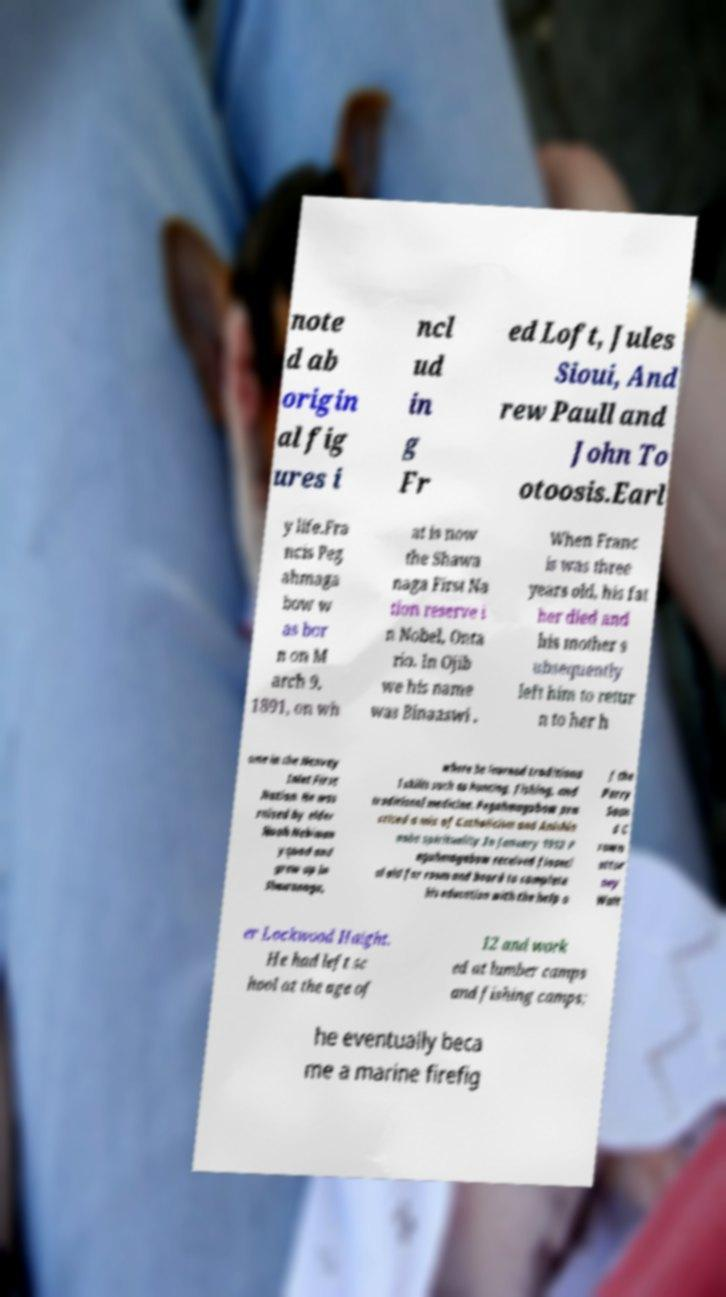What messages or text are displayed in this image? I need them in a readable, typed format. note d ab origin al fig ures i ncl ud in g Fr ed Loft, Jules Sioui, And rew Paull and John To otoosis.Earl y life.Fra ncis Peg ahmaga bow w as bor n on M arch 9, 1891, on wh at is now the Shawa naga First Na tion reserve i n Nobel, Onta rio. In Ojib we his name was Binaaswi . When Franc is was three years old, his fat her died and his mother s ubsequently left him to retur n to her h ome in the Henvey Inlet First Nation. He was raised by elder Noah Nebiman yquod and grew up in Shawanaga, where he learned traditiona l skills such as hunting, fishing, and traditional medicine. Pegahmagabow pra cticed a mix of Catholicism and Anishin aabe spirituality.In January 1912 P egahmagabow received financi al aid for room and board to complete his education with the help o f the Parry Soun d C rown attor ney Walt er Lockwood Haight. He had left sc hool at the age of 12 and work ed at lumber camps and fishing camps; he eventually beca me a marine firefig 